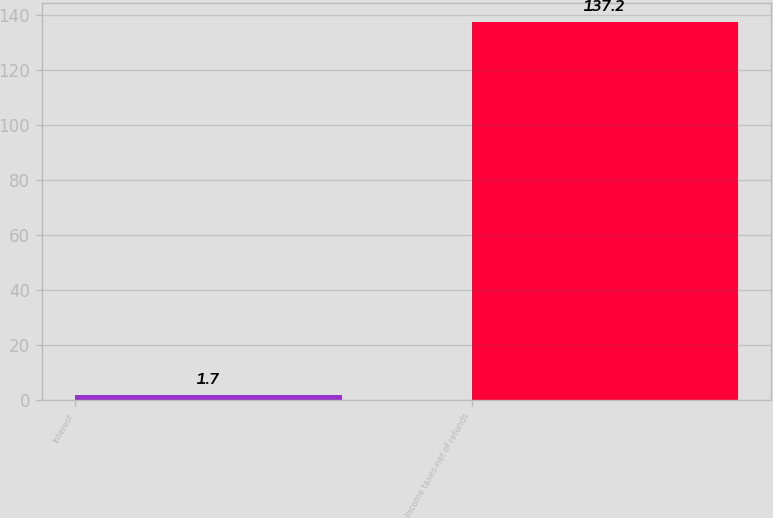<chart> <loc_0><loc_0><loc_500><loc_500><bar_chart><fcel>Interest<fcel>Income taxes-net of refunds<nl><fcel>1.7<fcel>137.2<nl></chart> 